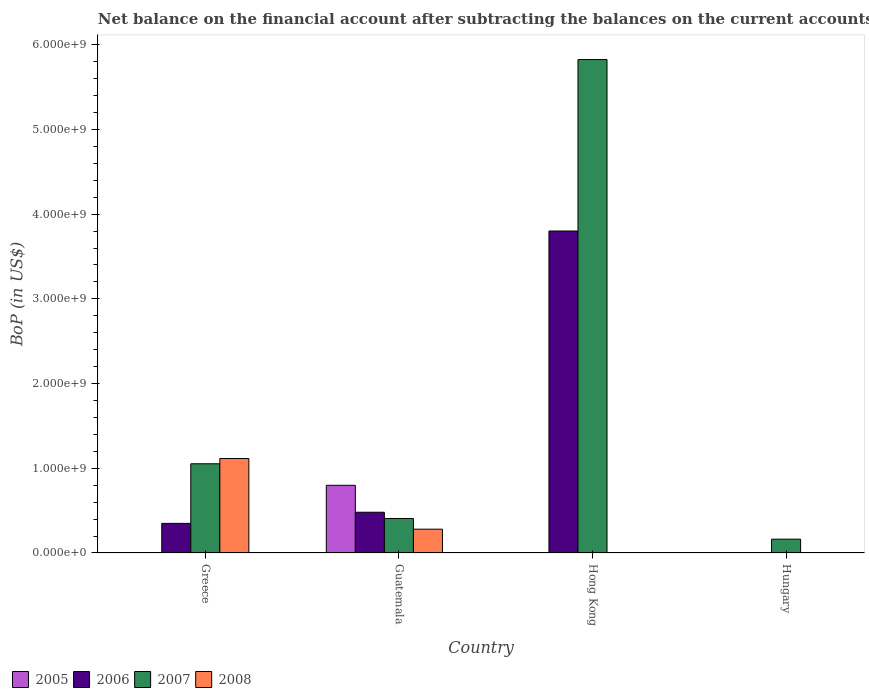Are the number of bars per tick equal to the number of legend labels?
Keep it short and to the point. No. What is the label of the 3rd group of bars from the left?
Ensure brevity in your answer.  Hong Kong. What is the Balance of Payments in 2007 in Hungary?
Your answer should be very brief. 1.63e+08. Across all countries, what is the maximum Balance of Payments in 2006?
Offer a terse response. 3.80e+09. In which country was the Balance of Payments in 2006 maximum?
Provide a succinct answer. Hong Kong. What is the total Balance of Payments in 2008 in the graph?
Your answer should be compact. 1.40e+09. What is the difference between the Balance of Payments in 2007 in Greece and that in Hungary?
Offer a terse response. 8.90e+08. What is the difference between the Balance of Payments in 2008 in Hungary and the Balance of Payments in 2007 in Hong Kong?
Keep it short and to the point. -5.83e+09. What is the average Balance of Payments in 2008 per country?
Make the answer very short. 3.49e+08. What is the difference between the Balance of Payments of/in 2007 and Balance of Payments of/in 2005 in Guatemala?
Provide a succinct answer. -3.92e+08. In how many countries, is the Balance of Payments in 2008 greater than 2000000000 US$?
Give a very brief answer. 0. What is the ratio of the Balance of Payments in 2006 in Greece to that in Hong Kong?
Make the answer very short. 0.09. What is the difference between the highest and the second highest Balance of Payments in 2007?
Your answer should be compact. -5.42e+09. What is the difference between the highest and the lowest Balance of Payments in 2008?
Your answer should be very brief. 1.12e+09. In how many countries, is the Balance of Payments in 2006 greater than the average Balance of Payments in 2006 taken over all countries?
Your answer should be compact. 1. Is the sum of the Balance of Payments in 2007 in Greece and Hong Kong greater than the maximum Balance of Payments in 2006 across all countries?
Keep it short and to the point. Yes. How many bars are there?
Your response must be concise. 10. Are all the bars in the graph horizontal?
Make the answer very short. No. What is the difference between two consecutive major ticks on the Y-axis?
Your response must be concise. 1.00e+09. How are the legend labels stacked?
Provide a succinct answer. Horizontal. What is the title of the graph?
Make the answer very short. Net balance on the financial account after subtracting the balances on the current accounts. Does "1984" appear as one of the legend labels in the graph?
Your response must be concise. No. What is the label or title of the Y-axis?
Your response must be concise. BoP (in US$). What is the BoP (in US$) of 2005 in Greece?
Provide a short and direct response. 0. What is the BoP (in US$) of 2006 in Greece?
Ensure brevity in your answer.  3.50e+08. What is the BoP (in US$) of 2007 in Greece?
Your response must be concise. 1.05e+09. What is the BoP (in US$) in 2008 in Greece?
Keep it short and to the point. 1.12e+09. What is the BoP (in US$) in 2005 in Guatemala?
Provide a succinct answer. 7.99e+08. What is the BoP (in US$) of 2006 in Guatemala?
Your answer should be compact. 4.81e+08. What is the BoP (in US$) in 2007 in Guatemala?
Provide a succinct answer. 4.07e+08. What is the BoP (in US$) of 2008 in Guatemala?
Make the answer very short. 2.81e+08. What is the BoP (in US$) in 2006 in Hong Kong?
Keep it short and to the point. 3.80e+09. What is the BoP (in US$) in 2007 in Hong Kong?
Provide a succinct answer. 5.83e+09. What is the BoP (in US$) in 2005 in Hungary?
Keep it short and to the point. 0. What is the BoP (in US$) in 2007 in Hungary?
Your answer should be very brief. 1.63e+08. What is the BoP (in US$) in 2008 in Hungary?
Give a very brief answer. 0. Across all countries, what is the maximum BoP (in US$) in 2005?
Provide a short and direct response. 7.99e+08. Across all countries, what is the maximum BoP (in US$) of 2006?
Offer a very short reply. 3.80e+09. Across all countries, what is the maximum BoP (in US$) of 2007?
Make the answer very short. 5.83e+09. Across all countries, what is the maximum BoP (in US$) in 2008?
Offer a very short reply. 1.12e+09. Across all countries, what is the minimum BoP (in US$) in 2005?
Your answer should be compact. 0. Across all countries, what is the minimum BoP (in US$) in 2007?
Provide a succinct answer. 1.63e+08. What is the total BoP (in US$) of 2005 in the graph?
Make the answer very short. 7.99e+08. What is the total BoP (in US$) in 2006 in the graph?
Ensure brevity in your answer.  4.63e+09. What is the total BoP (in US$) of 2007 in the graph?
Ensure brevity in your answer.  7.45e+09. What is the total BoP (in US$) in 2008 in the graph?
Ensure brevity in your answer.  1.40e+09. What is the difference between the BoP (in US$) in 2006 in Greece and that in Guatemala?
Provide a short and direct response. -1.31e+08. What is the difference between the BoP (in US$) of 2007 in Greece and that in Guatemala?
Offer a terse response. 6.46e+08. What is the difference between the BoP (in US$) of 2008 in Greece and that in Guatemala?
Provide a succinct answer. 8.34e+08. What is the difference between the BoP (in US$) of 2006 in Greece and that in Hong Kong?
Offer a very short reply. -3.45e+09. What is the difference between the BoP (in US$) in 2007 in Greece and that in Hong Kong?
Your answer should be compact. -4.77e+09. What is the difference between the BoP (in US$) in 2007 in Greece and that in Hungary?
Offer a terse response. 8.90e+08. What is the difference between the BoP (in US$) of 2006 in Guatemala and that in Hong Kong?
Keep it short and to the point. -3.32e+09. What is the difference between the BoP (in US$) in 2007 in Guatemala and that in Hong Kong?
Make the answer very short. -5.42e+09. What is the difference between the BoP (in US$) of 2007 in Guatemala and that in Hungary?
Offer a very short reply. 2.44e+08. What is the difference between the BoP (in US$) in 2007 in Hong Kong and that in Hungary?
Offer a terse response. 5.66e+09. What is the difference between the BoP (in US$) of 2006 in Greece and the BoP (in US$) of 2007 in Guatemala?
Ensure brevity in your answer.  -5.78e+07. What is the difference between the BoP (in US$) of 2006 in Greece and the BoP (in US$) of 2008 in Guatemala?
Offer a very short reply. 6.85e+07. What is the difference between the BoP (in US$) of 2007 in Greece and the BoP (in US$) of 2008 in Guatemala?
Your response must be concise. 7.72e+08. What is the difference between the BoP (in US$) in 2006 in Greece and the BoP (in US$) in 2007 in Hong Kong?
Keep it short and to the point. -5.48e+09. What is the difference between the BoP (in US$) in 2006 in Greece and the BoP (in US$) in 2007 in Hungary?
Provide a short and direct response. 1.86e+08. What is the difference between the BoP (in US$) in 2005 in Guatemala and the BoP (in US$) in 2006 in Hong Kong?
Ensure brevity in your answer.  -3.00e+09. What is the difference between the BoP (in US$) in 2005 in Guatemala and the BoP (in US$) in 2007 in Hong Kong?
Provide a succinct answer. -5.03e+09. What is the difference between the BoP (in US$) in 2006 in Guatemala and the BoP (in US$) in 2007 in Hong Kong?
Your answer should be compact. -5.34e+09. What is the difference between the BoP (in US$) of 2005 in Guatemala and the BoP (in US$) of 2007 in Hungary?
Give a very brief answer. 6.36e+08. What is the difference between the BoP (in US$) in 2006 in Guatemala and the BoP (in US$) in 2007 in Hungary?
Your answer should be very brief. 3.18e+08. What is the difference between the BoP (in US$) in 2006 in Hong Kong and the BoP (in US$) in 2007 in Hungary?
Make the answer very short. 3.64e+09. What is the average BoP (in US$) of 2005 per country?
Provide a succinct answer. 2.00e+08. What is the average BoP (in US$) in 2006 per country?
Make the answer very short. 1.16e+09. What is the average BoP (in US$) in 2007 per country?
Offer a terse response. 1.86e+09. What is the average BoP (in US$) of 2008 per country?
Your answer should be very brief. 3.49e+08. What is the difference between the BoP (in US$) of 2006 and BoP (in US$) of 2007 in Greece?
Offer a very short reply. -7.04e+08. What is the difference between the BoP (in US$) in 2006 and BoP (in US$) in 2008 in Greece?
Offer a terse response. -7.65e+08. What is the difference between the BoP (in US$) of 2007 and BoP (in US$) of 2008 in Greece?
Provide a short and direct response. -6.17e+07. What is the difference between the BoP (in US$) of 2005 and BoP (in US$) of 2006 in Guatemala?
Offer a terse response. 3.18e+08. What is the difference between the BoP (in US$) of 2005 and BoP (in US$) of 2007 in Guatemala?
Offer a very short reply. 3.92e+08. What is the difference between the BoP (in US$) of 2005 and BoP (in US$) of 2008 in Guatemala?
Your answer should be compact. 5.18e+08. What is the difference between the BoP (in US$) of 2006 and BoP (in US$) of 2007 in Guatemala?
Your response must be concise. 7.36e+07. What is the difference between the BoP (in US$) of 2006 and BoP (in US$) of 2008 in Guatemala?
Offer a terse response. 2.00e+08. What is the difference between the BoP (in US$) in 2007 and BoP (in US$) in 2008 in Guatemala?
Offer a terse response. 1.26e+08. What is the difference between the BoP (in US$) of 2006 and BoP (in US$) of 2007 in Hong Kong?
Your answer should be compact. -2.02e+09. What is the ratio of the BoP (in US$) of 2006 in Greece to that in Guatemala?
Your response must be concise. 0.73. What is the ratio of the BoP (in US$) of 2007 in Greece to that in Guatemala?
Your answer should be very brief. 2.59. What is the ratio of the BoP (in US$) in 2008 in Greece to that in Guatemala?
Offer a terse response. 3.97. What is the ratio of the BoP (in US$) in 2006 in Greece to that in Hong Kong?
Provide a succinct answer. 0.09. What is the ratio of the BoP (in US$) in 2007 in Greece to that in Hong Kong?
Ensure brevity in your answer.  0.18. What is the ratio of the BoP (in US$) in 2007 in Greece to that in Hungary?
Make the answer very short. 6.45. What is the ratio of the BoP (in US$) in 2006 in Guatemala to that in Hong Kong?
Provide a succinct answer. 0.13. What is the ratio of the BoP (in US$) in 2007 in Guatemala to that in Hong Kong?
Your answer should be very brief. 0.07. What is the ratio of the BoP (in US$) of 2007 in Guatemala to that in Hungary?
Offer a very short reply. 2.5. What is the ratio of the BoP (in US$) of 2007 in Hong Kong to that in Hungary?
Make the answer very short. 35.69. What is the difference between the highest and the second highest BoP (in US$) of 2006?
Your answer should be compact. 3.32e+09. What is the difference between the highest and the second highest BoP (in US$) of 2007?
Keep it short and to the point. 4.77e+09. What is the difference between the highest and the lowest BoP (in US$) of 2005?
Your response must be concise. 7.99e+08. What is the difference between the highest and the lowest BoP (in US$) in 2006?
Your response must be concise. 3.80e+09. What is the difference between the highest and the lowest BoP (in US$) in 2007?
Offer a terse response. 5.66e+09. What is the difference between the highest and the lowest BoP (in US$) in 2008?
Your response must be concise. 1.12e+09. 